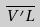Convert formula to latex. <formula><loc_0><loc_0><loc_500><loc_500>\overline { V ^ { \prime } L }</formula> 